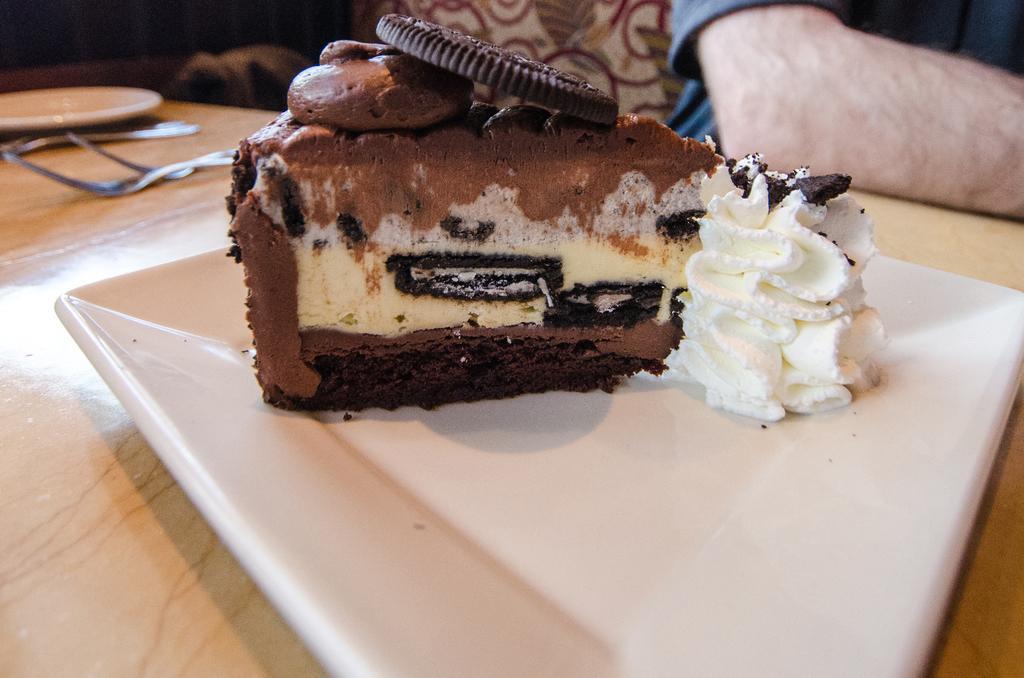In one or two sentences, can you explain what this image depicts? In the image we can see a wooden surface. There is a plate, white in color, in the plate we can see a piece of cake. These are the spoons and a human hand. 